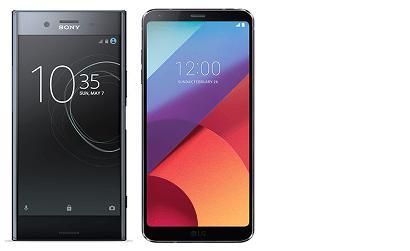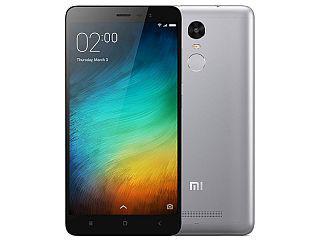The first image is the image on the left, the second image is the image on the right. Assess this claim about the two images: "There are no more than 2 phones.". Correct or not? Answer yes or no. No. The first image is the image on the left, the second image is the image on the right. Evaluate the accuracy of this statement regarding the images: "there are two phones in the image pair". Is it true? Answer yes or no. No. 